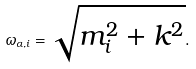Convert formula to latex. <formula><loc_0><loc_0><loc_500><loc_500>\omega _ { \alpha , i } = \sqrt { m _ { i } ^ { 2 } + { k } ^ { 2 } } .</formula> 